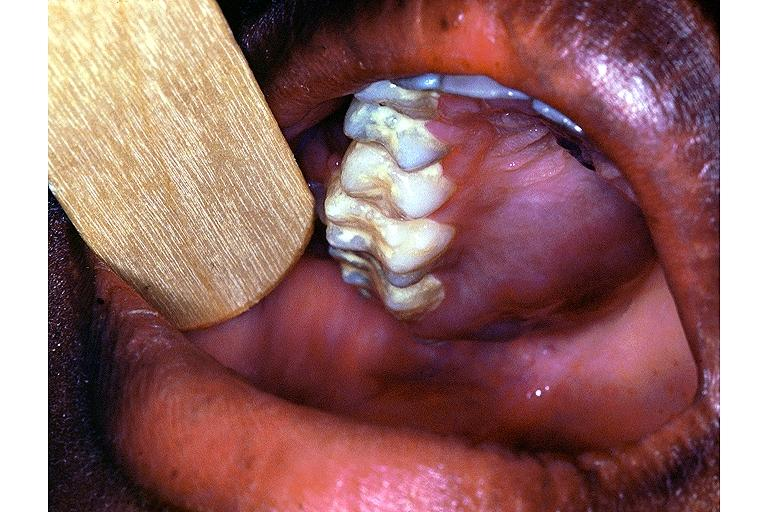what does this image show?
Answer the question using a single word or phrase. Burkit lymphoma 